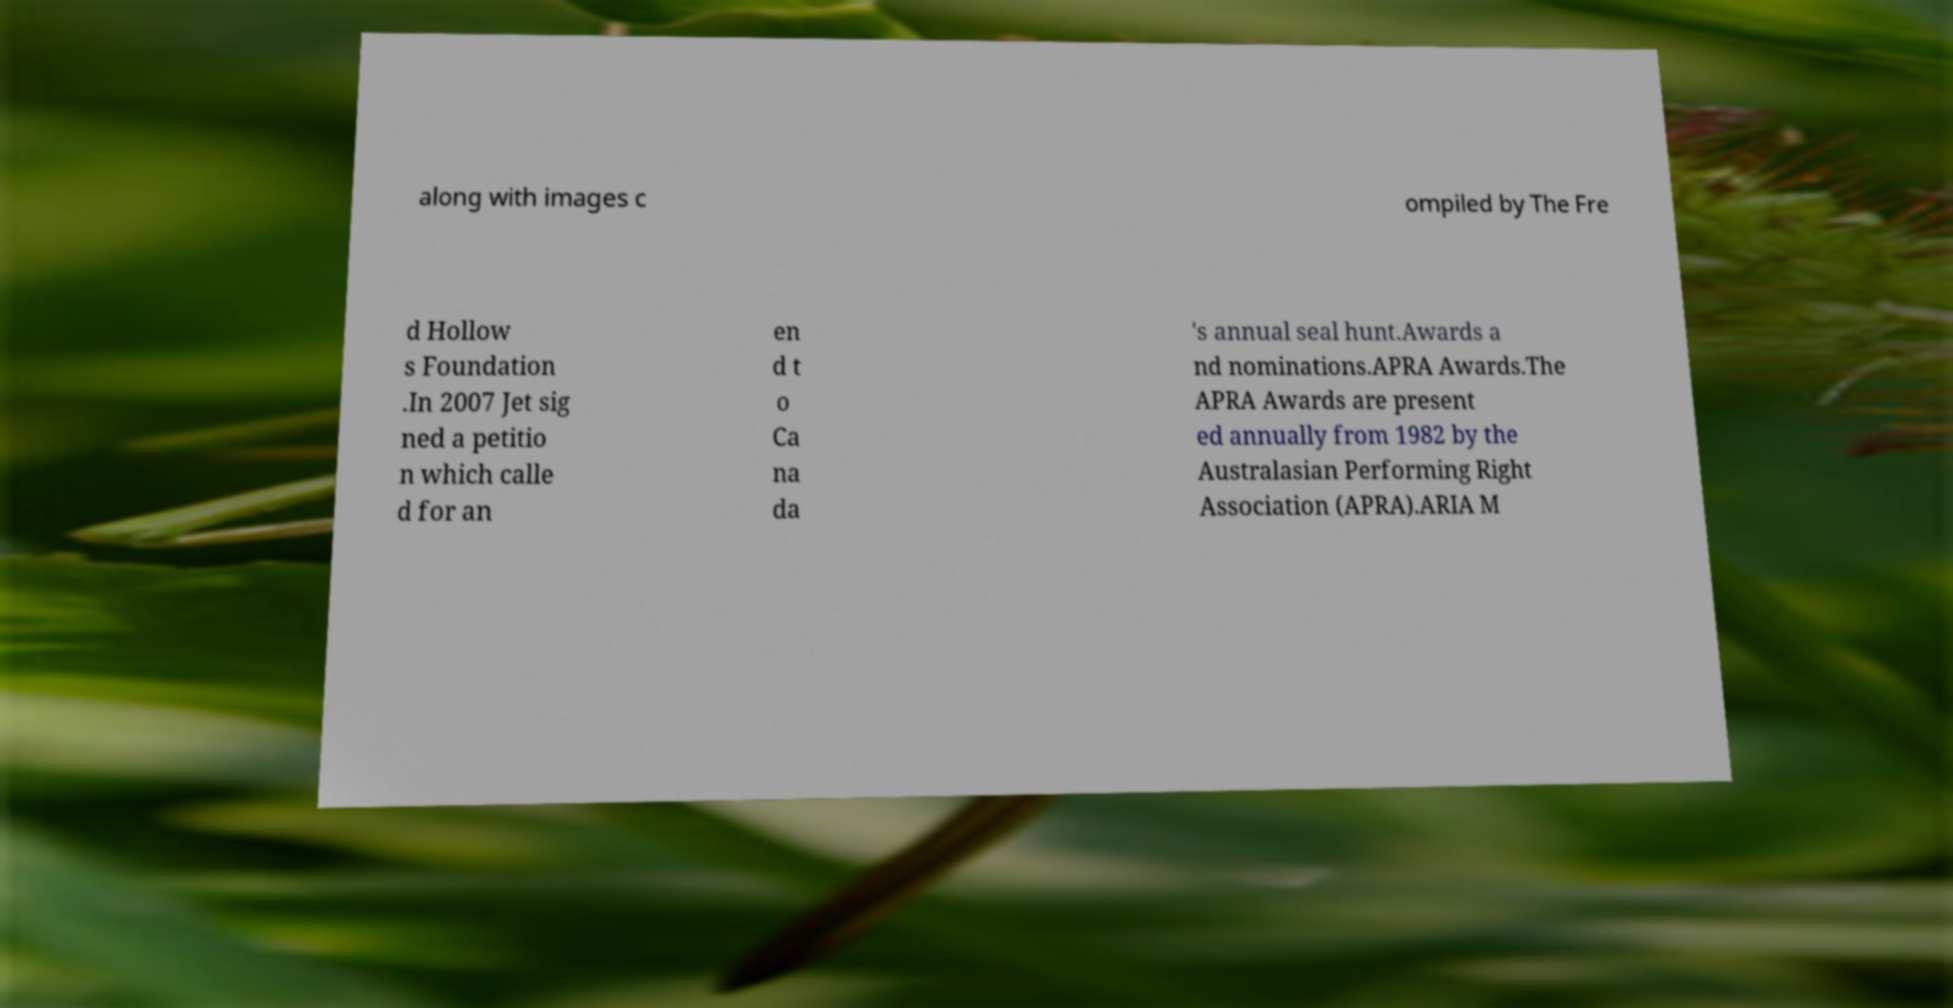What messages or text are displayed in this image? I need them in a readable, typed format. along with images c ompiled by The Fre d Hollow s Foundation .In 2007 Jet sig ned a petitio n which calle d for an en d t o Ca na da 's annual seal hunt.Awards a nd nominations.APRA Awards.The APRA Awards are present ed annually from 1982 by the Australasian Performing Right Association (APRA).ARIA M 